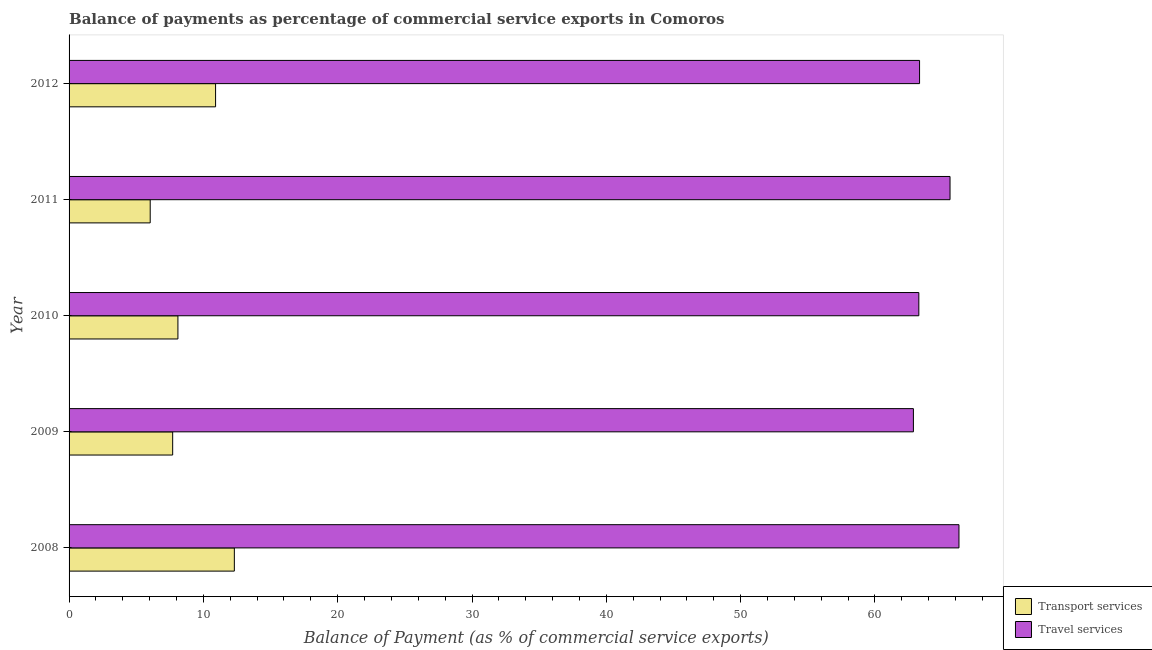How many groups of bars are there?
Provide a short and direct response. 5. Are the number of bars per tick equal to the number of legend labels?
Your response must be concise. Yes. Are the number of bars on each tick of the Y-axis equal?
Offer a terse response. Yes. How many bars are there on the 2nd tick from the bottom?
Your response must be concise. 2. What is the balance of payments of travel services in 2010?
Offer a very short reply. 63.27. Across all years, what is the maximum balance of payments of travel services?
Keep it short and to the point. 66.26. Across all years, what is the minimum balance of payments of travel services?
Keep it short and to the point. 62.86. In which year was the balance of payments of transport services minimum?
Provide a short and direct response. 2011. What is the total balance of payments of travel services in the graph?
Ensure brevity in your answer.  321.3. What is the difference between the balance of payments of transport services in 2009 and that in 2010?
Keep it short and to the point. -0.39. What is the difference between the balance of payments of transport services in 2008 and the balance of payments of travel services in 2009?
Offer a very short reply. -50.56. What is the average balance of payments of transport services per year?
Your answer should be compact. 9.02. In the year 2008, what is the difference between the balance of payments of transport services and balance of payments of travel services?
Offer a very short reply. -53.95. What is the ratio of the balance of payments of transport services in 2009 to that in 2012?
Offer a terse response. 0.71. What is the difference between the highest and the second highest balance of payments of travel services?
Your response must be concise. 0.67. What is the difference between the highest and the lowest balance of payments of travel services?
Your answer should be compact. 3.39. In how many years, is the balance of payments of transport services greater than the average balance of payments of transport services taken over all years?
Keep it short and to the point. 2. What does the 1st bar from the top in 2011 represents?
Keep it short and to the point. Travel services. What does the 2nd bar from the bottom in 2012 represents?
Ensure brevity in your answer.  Travel services. What is the difference between two consecutive major ticks on the X-axis?
Your response must be concise. 10. Are the values on the major ticks of X-axis written in scientific E-notation?
Your response must be concise. No. Does the graph contain any zero values?
Give a very brief answer. No. Where does the legend appear in the graph?
Give a very brief answer. Bottom right. How are the legend labels stacked?
Make the answer very short. Vertical. What is the title of the graph?
Make the answer very short. Balance of payments as percentage of commercial service exports in Comoros. Does "Commercial bank branches" appear as one of the legend labels in the graph?
Keep it short and to the point. No. What is the label or title of the X-axis?
Your response must be concise. Balance of Payment (as % of commercial service exports). What is the Balance of Payment (as % of commercial service exports) in Transport services in 2008?
Offer a very short reply. 12.31. What is the Balance of Payment (as % of commercial service exports) of Travel services in 2008?
Your answer should be compact. 66.26. What is the Balance of Payment (as % of commercial service exports) of Transport services in 2009?
Offer a terse response. 7.71. What is the Balance of Payment (as % of commercial service exports) of Travel services in 2009?
Make the answer very short. 62.86. What is the Balance of Payment (as % of commercial service exports) of Transport services in 2010?
Offer a terse response. 8.1. What is the Balance of Payment (as % of commercial service exports) in Travel services in 2010?
Provide a short and direct response. 63.27. What is the Balance of Payment (as % of commercial service exports) in Transport services in 2011?
Provide a short and direct response. 6.04. What is the Balance of Payment (as % of commercial service exports) of Travel services in 2011?
Offer a terse response. 65.59. What is the Balance of Payment (as % of commercial service exports) in Transport services in 2012?
Give a very brief answer. 10.91. What is the Balance of Payment (as % of commercial service exports) of Travel services in 2012?
Provide a succinct answer. 63.32. Across all years, what is the maximum Balance of Payment (as % of commercial service exports) of Transport services?
Ensure brevity in your answer.  12.31. Across all years, what is the maximum Balance of Payment (as % of commercial service exports) in Travel services?
Your response must be concise. 66.26. Across all years, what is the minimum Balance of Payment (as % of commercial service exports) of Transport services?
Your response must be concise. 6.04. Across all years, what is the minimum Balance of Payment (as % of commercial service exports) of Travel services?
Provide a succinct answer. 62.86. What is the total Balance of Payment (as % of commercial service exports) in Transport services in the graph?
Keep it short and to the point. 45.07. What is the total Balance of Payment (as % of commercial service exports) of Travel services in the graph?
Your response must be concise. 321.3. What is the difference between the Balance of Payment (as % of commercial service exports) of Transport services in 2008 and that in 2009?
Provide a short and direct response. 4.59. What is the difference between the Balance of Payment (as % of commercial service exports) in Travel services in 2008 and that in 2009?
Offer a very short reply. 3.39. What is the difference between the Balance of Payment (as % of commercial service exports) in Transport services in 2008 and that in 2010?
Your response must be concise. 4.2. What is the difference between the Balance of Payment (as % of commercial service exports) of Travel services in 2008 and that in 2010?
Give a very brief answer. 2.99. What is the difference between the Balance of Payment (as % of commercial service exports) in Transport services in 2008 and that in 2011?
Provide a short and direct response. 6.26. What is the difference between the Balance of Payment (as % of commercial service exports) of Travel services in 2008 and that in 2011?
Offer a terse response. 0.66. What is the difference between the Balance of Payment (as % of commercial service exports) in Transport services in 2008 and that in 2012?
Make the answer very short. 1.4. What is the difference between the Balance of Payment (as % of commercial service exports) in Travel services in 2008 and that in 2012?
Your answer should be very brief. 2.93. What is the difference between the Balance of Payment (as % of commercial service exports) in Transport services in 2009 and that in 2010?
Offer a terse response. -0.39. What is the difference between the Balance of Payment (as % of commercial service exports) in Travel services in 2009 and that in 2010?
Provide a short and direct response. -0.4. What is the difference between the Balance of Payment (as % of commercial service exports) in Transport services in 2009 and that in 2011?
Give a very brief answer. 1.67. What is the difference between the Balance of Payment (as % of commercial service exports) of Travel services in 2009 and that in 2011?
Make the answer very short. -2.73. What is the difference between the Balance of Payment (as % of commercial service exports) in Transport services in 2009 and that in 2012?
Keep it short and to the point. -3.19. What is the difference between the Balance of Payment (as % of commercial service exports) of Travel services in 2009 and that in 2012?
Make the answer very short. -0.46. What is the difference between the Balance of Payment (as % of commercial service exports) in Transport services in 2010 and that in 2011?
Your answer should be very brief. 2.06. What is the difference between the Balance of Payment (as % of commercial service exports) of Travel services in 2010 and that in 2011?
Keep it short and to the point. -2.32. What is the difference between the Balance of Payment (as % of commercial service exports) in Transport services in 2010 and that in 2012?
Keep it short and to the point. -2.8. What is the difference between the Balance of Payment (as % of commercial service exports) of Travel services in 2010 and that in 2012?
Provide a short and direct response. -0.05. What is the difference between the Balance of Payment (as % of commercial service exports) in Transport services in 2011 and that in 2012?
Your response must be concise. -4.87. What is the difference between the Balance of Payment (as % of commercial service exports) of Travel services in 2011 and that in 2012?
Provide a succinct answer. 2.27. What is the difference between the Balance of Payment (as % of commercial service exports) of Transport services in 2008 and the Balance of Payment (as % of commercial service exports) of Travel services in 2009?
Your response must be concise. -50.56. What is the difference between the Balance of Payment (as % of commercial service exports) of Transport services in 2008 and the Balance of Payment (as % of commercial service exports) of Travel services in 2010?
Your answer should be compact. -50.96. What is the difference between the Balance of Payment (as % of commercial service exports) of Transport services in 2008 and the Balance of Payment (as % of commercial service exports) of Travel services in 2011?
Keep it short and to the point. -53.29. What is the difference between the Balance of Payment (as % of commercial service exports) in Transport services in 2008 and the Balance of Payment (as % of commercial service exports) in Travel services in 2012?
Ensure brevity in your answer.  -51.02. What is the difference between the Balance of Payment (as % of commercial service exports) in Transport services in 2009 and the Balance of Payment (as % of commercial service exports) in Travel services in 2010?
Provide a short and direct response. -55.55. What is the difference between the Balance of Payment (as % of commercial service exports) in Transport services in 2009 and the Balance of Payment (as % of commercial service exports) in Travel services in 2011?
Keep it short and to the point. -57.88. What is the difference between the Balance of Payment (as % of commercial service exports) in Transport services in 2009 and the Balance of Payment (as % of commercial service exports) in Travel services in 2012?
Provide a succinct answer. -55.61. What is the difference between the Balance of Payment (as % of commercial service exports) in Transport services in 2010 and the Balance of Payment (as % of commercial service exports) in Travel services in 2011?
Offer a very short reply. -57.49. What is the difference between the Balance of Payment (as % of commercial service exports) in Transport services in 2010 and the Balance of Payment (as % of commercial service exports) in Travel services in 2012?
Provide a succinct answer. -55.22. What is the difference between the Balance of Payment (as % of commercial service exports) of Transport services in 2011 and the Balance of Payment (as % of commercial service exports) of Travel services in 2012?
Offer a terse response. -57.28. What is the average Balance of Payment (as % of commercial service exports) in Transport services per year?
Your response must be concise. 9.01. What is the average Balance of Payment (as % of commercial service exports) of Travel services per year?
Make the answer very short. 64.26. In the year 2008, what is the difference between the Balance of Payment (as % of commercial service exports) of Transport services and Balance of Payment (as % of commercial service exports) of Travel services?
Provide a succinct answer. -53.95. In the year 2009, what is the difference between the Balance of Payment (as % of commercial service exports) of Transport services and Balance of Payment (as % of commercial service exports) of Travel services?
Give a very brief answer. -55.15. In the year 2010, what is the difference between the Balance of Payment (as % of commercial service exports) in Transport services and Balance of Payment (as % of commercial service exports) in Travel services?
Offer a terse response. -55.16. In the year 2011, what is the difference between the Balance of Payment (as % of commercial service exports) of Transport services and Balance of Payment (as % of commercial service exports) of Travel services?
Give a very brief answer. -59.55. In the year 2012, what is the difference between the Balance of Payment (as % of commercial service exports) in Transport services and Balance of Payment (as % of commercial service exports) in Travel services?
Provide a short and direct response. -52.41. What is the ratio of the Balance of Payment (as % of commercial service exports) in Transport services in 2008 to that in 2009?
Provide a short and direct response. 1.6. What is the ratio of the Balance of Payment (as % of commercial service exports) of Travel services in 2008 to that in 2009?
Ensure brevity in your answer.  1.05. What is the ratio of the Balance of Payment (as % of commercial service exports) of Transport services in 2008 to that in 2010?
Give a very brief answer. 1.52. What is the ratio of the Balance of Payment (as % of commercial service exports) of Travel services in 2008 to that in 2010?
Offer a terse response. 1.05. What is the ratio of the Balance of Payment (as % of commercial service exports) of Transport services in 2008 to that in 2011?
Make the answer very short. 2.04. What is the ratio of the Balance of Payment (as % of commercial service exports) of Travel services in 2008 to that in 2011?
Provide a succinct answer. 1.01. What is the ratio of the Balance of Payment (as % of commercial service exports) in Transport services in 2008 to that in 2012?
Keep it short and to the point. 1.13. What is the ratio of the Balance of Payment (as % of commercial service exports) in Travel services in 2008 to that in 2012?
Offer a very short reply. 1.05. What is the ratio of the Balance of Payment (as % of commercial service exports) of Transport services in 2009 to that in 2010?
Ensure brevity in your answer.  0.95. What is the ratio of the Balance of Payment (as % of commercial service exports) in Transport services in 2009 to that in 2011?
Provide a succinct answer. 1.28. What is the ratio of the Balance of Payment (as % of commercial service exports) of Travel services in 2009 to that in 2011?
Keep it short and to the point. 0.96. What is the ratio of the Balance of Payment (as % of commercial service exports) of Transport services in 2009 to that in 2012?
Your answer should be very brief. 0.71. What is the ratio of the Balance of Payment (as % of commercial service exports) of Transport services in 2010 to that in 2011?
Your answer should be very brief. 1.34. What is the ratio of the Balance of Payment (as % of commercial service exports) of Travel services in 2010 to that in 2011?
Offer a very short reply. 0.96. What is the ratio of the Balance of Payment (as % of commercial service exports) in Transport services in 2010 to that in 2012?
Your answer should be compact. 0.74. What is the ratio of the Balance of Payment (as % of commercial service exports) of Travel services in 2010 to that in 2012?
Your answer should be compact. 1. What is the ratio of the Balance of Payment (as % of commercial service exports) of Transport services in 2011 to that in 2012?
Give a very brief answer. 0.55. What is the ratio of the Balance of Payment (as % of commercial service exports) of Travel services in 2011 to that in 2012?
Give a very brief answer. 1.04. What is the difference between the highest and the second highest Balance of Payment (as % of commercial service exports) of Transport services?
Ensure brevity in your answer.  1.4. What is the difference between the highest and the second highest Balance of Payment (as % of commercial service exports) of Travel services?
Ensure brevity in your answer.  0.66. What is the difference between the highest and the lowest Balance of Payment (as % of commercial service exports) in Transport services?
Keep it short and to the point. 6.26. What is the difference between the highest and the lowest Balance of Payment (as % of commercial service exports) of Travel services?
Keep it short and to the point. 3.39. 